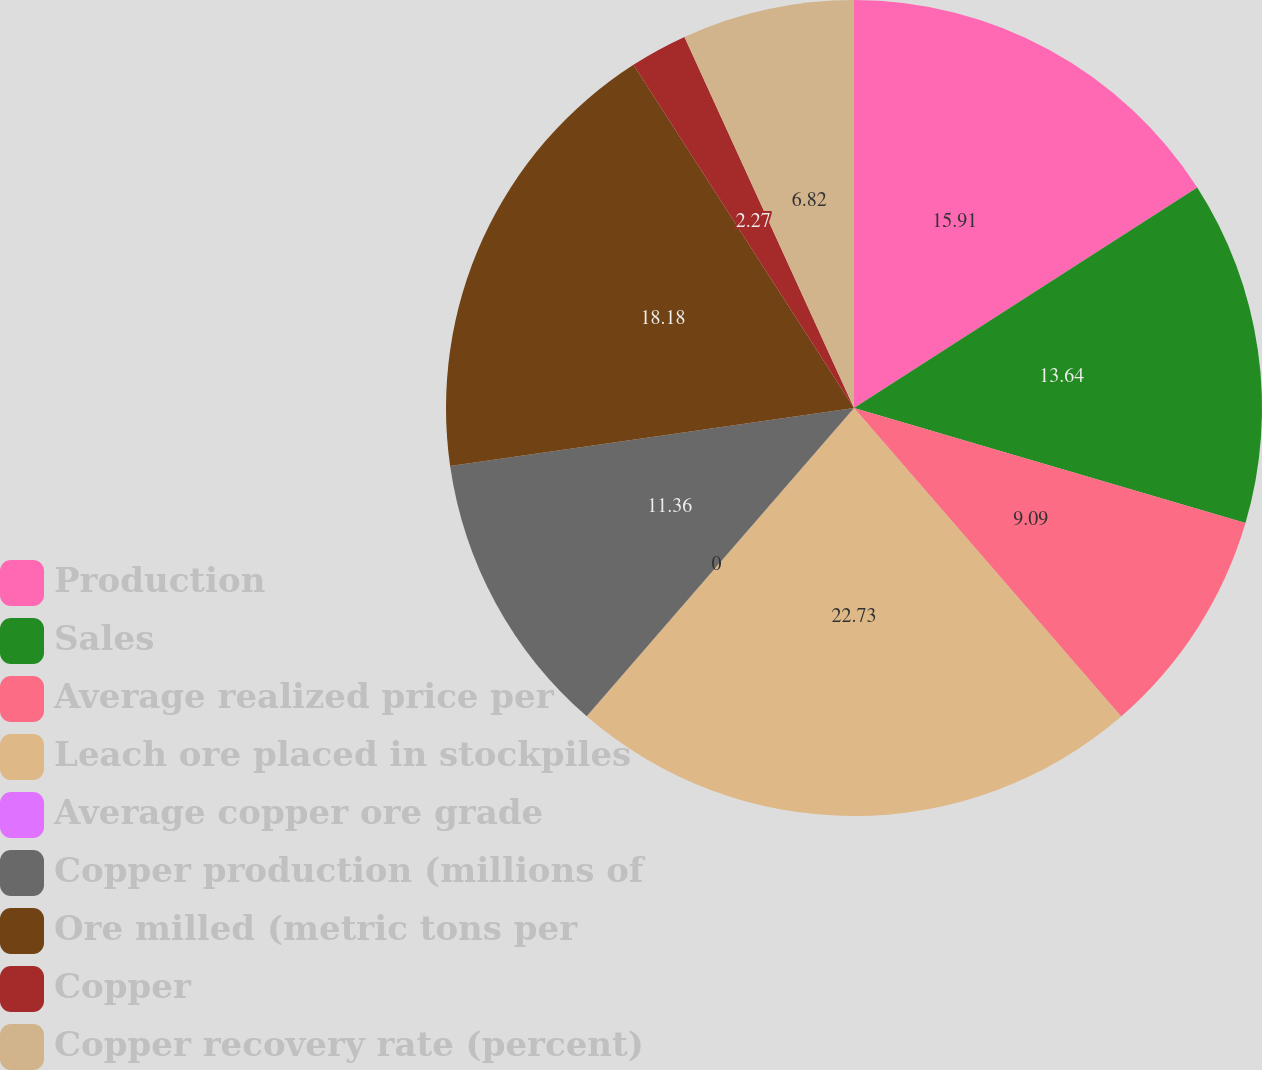Convert chart. <chart><loc_0><loc_0><loc_500><loc_500><pie_chart><fcel>Production<fcel>Sales<fcel>Average realized price per<fcel>Leach ore placed in stockpiles<fcel>Average copper ore grade<fcel>Copper production (millions of<fcel>Ore milled (metric tons per<fcel>Copper<fcel>Copper recovery rate (percent)<nl><fcel>15.91%<fcel>13.64%<fcel>9.09%<fcel>22.73%<fcel>0.0%<fcel>11.36%<fcel>18.18%<fcel>2.27%<fcel>6.82%<nl></chart> 